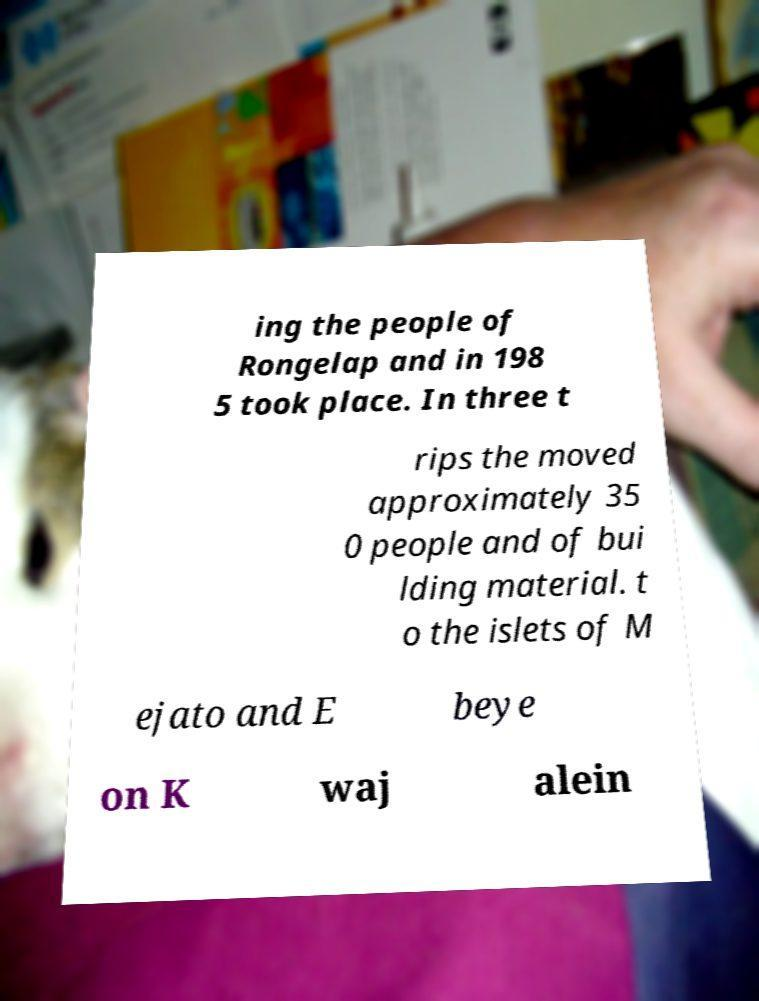Can you accurately transcribe the text from the provided image for me? ing the people of Rongelap and in 198 5 took place. In three t rips the moved approximately 35 0 people and of bui lding material. t o the islets of M ejato and E beye on K waj alein 